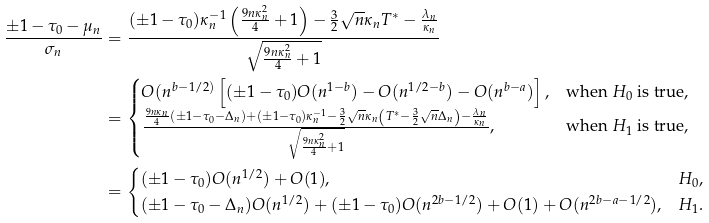<formula> <loc_0><loc_0><loc_500><loc_500>\frac { \pm 1 - \tau _ { 0 } - \mu _ { n } } { \sigma _ { n } } & = \frac { ( \pm 1 - \tau _ { 0 } ) \kappa _ { n } ^ { - 1 } \left ( \frac { 9 n \kappa _ { n } ^ { 2 } } { 4 } + 1 \right ) - \frac { 3 } { 2 } \sqrt { n } \kappa _ { n } T ^ { * } - \frac { \lambda _ { n } } { \kappa _ { n } } } { \sqrt { \frac { 9 n \kappa _ { n } ^ { 2 } } { 4 } + 1 } } \\ & = \begin{cases} O ( n ^ { b - 1 / 2 ) } \left [ ( \pm 1 - \tau _ { 0 } ) O ( n ^ { 1 - b } ) - O ( n ^ { 1 / 2 - b } ) - O ( n ^ { b - a } ) \right ] , & \text {when $H_{0}$ is true} , \\ \frac { \frac { 9 n \kappa _ { n } } { 4 } \left ( \pm 1 - \tau _ { 0 } - \Delta _ { n } \right ) + ( \pm 1 - \tau _ { 0 } ) \kappa _ { n } ^ { - 1 } - \frac { 3 } { 2 } \sqrt { n } \kappa _ { n } \left ( T ^ { * } - \frac { 3 } { 2 } \sqrt { n } \Delta _ { n } \right ) - \frac { \lambda _ { n } } { \kappa _ { n } } } { \sqrt { \frac { 9 n \kappa _ { n } ^ { 2 } } { 4 } + 1 } } , & \text {when $H_{1}$ is true} , \end{cases} \\ & = \begin{cases} ( \pm 1 - \tau _ { 0 } ) O ( n ^ { 1 / 2 } ) + O ( 1 ) , & H _ { 0 } , \\ ( \pm 1 - \tau _ { 0 } - \Delta _ { n } ) O ( n ^ { 1 / 2 } ) + ( \pm 1 - \tau _ { 0 } ) O ( n ^ { 2 b - 1 / 2 } ) + O ( 1 ) + O ( n ^ { 2 b - a - 1 / 2 } ) , & H _ { 1 } . \end{cases}</formula> 